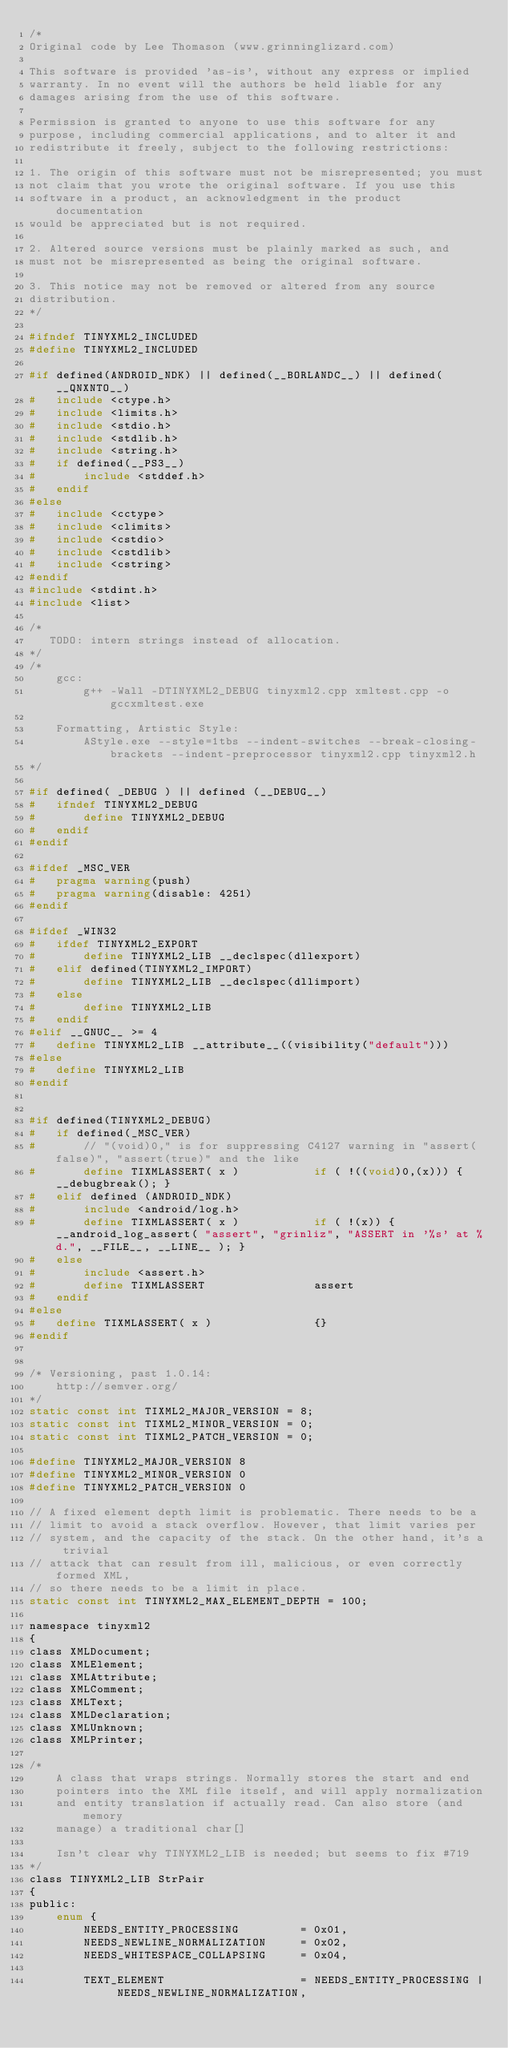Convert code to text. <code><loc_0><loc_0><loc_500><loc_500><_C_>/*
Original code by Lee Thomason (www.grinninglizard.com)

This software is provided 'as-is', without any express or implied
warranty. In no event will the authors be held liable for any
damages arising from the use of this software.

Permission is granted to anyone to use this software for any
purpose, including commercial applications, and to alter it and
redistribute it freely, subject to the following restrictions:

1. The origin of this software must not be misrepresented; you must
not claim that you wrote the original software. If you use this
software in a product, an acknowledgment in the product documentation
would be appreciated but is not required.

2. Altered source versions must be plainly marked as such, and
must not be misrepresented as being the original software.

3. This notice may not be removed or altered from any source
distribution.
*/

#ifndef TINYXML2_INCLUDED
#define TINYXML2_INCLUDED

#if defined(ANDROID_NDK) || defined(__BORLANDC__) || defined(__QNXNTO__)
#   include <ctype.h>
#   include <limits.h>
#   include <stdio.h>
#   include <stdlib.h>
#   include <string.h>
#	if defined(__PS3__)
#		include <stddef.h>
#	endif
#else
#   include <cctype>
#   include <climits>
#   include <cstdio>
#   include <cstdlib>
#   include <cstring>
#endif
#include <stdint.h>
#include <list>

/*
   TODO: intern strings instead of allocation.
*/
/*
	gcc:
        g++ -Wall -DTINYXML2_DEBUG tinyxml2.cpp xmltest.cpp -o gccxmltest.exe

    Formatting, Artistic Style:
        AStyle.exe --style=1tbs --indent-switches --break-closing-brackets --indent-preprocessor tinyxml2.cpp tinyxml2.h
*/

#if defined( _DEBUG ) || defined (__DEBUG__)
#   ifndef TINYXML2_DEBUG
#       define TINYXML2_DEBUG
#   endif
#endif

#ifdef _MSC_VER
#   pragma warning(push)
#   pragma warning(disable: 4251)
#endif

#ifdef _WIN32
#   ifdef TINYXML2_EXPORT
#       define TINYXML2_LIB __declspec(dllexport)
#   elif defined(TINYXML2_IMPORT)
#       define TINYXML2_LIB __declspec(dllimport)
#   else
#       define TINYXML2_LIB
#   endif
#elif __GNUC__ >= 4
#   define TINYXML2_LIB __attribute__((visibility("default")))
#else
#   define TINYXML2_LIB
#endif


#if defined(TINYXML2_DEBUG)
#   if defined(_MSC_VER)
#       // "(void)0," is for suppressing C4127 warning in "assert(false)", "assert(true)" and the like
#       define TIXMLASSERT( x )           if ( !((void)0,(x))) { __debugbreak(); }
#   elif defined (ANDROID_NDK)
#       include <android/log.h>
#       define TIXMLASSERT( x )           if ( !(x)) { __android_log_assert( "assert", "grinliz", "ASSERT in '%s' at %d.", __FILE__, __LINE__ ); }
#   else
#       include <assert.h>
#       define TIXMLASSERT                assert
#   endif
#else
#   define TIXMLASSERT( x )               {}
#endif


/* Versioning, past 1.0.14:
	http://semver.org/
*/
static const int TIXML2_MAJOR_VERSION = 8;
static const int TIXML2_MINOR_VERSION = 0;
static const int TIXML2_PATCH_VERSION = 0;

#define TINYXML2_MAJOR_VERSION 8
#define TINYXML2_MINOR_VERSION 0
#define TINYXML2_PATCH_VERSION 0

// A fixed element depth limit is problematic. There needs to be a
// limit to avoid a stack overflow. However, that limit varies per
// system, and the capacity of the stack. On the other hand, it's a trivial
// attack that can result from ill, malicious, or even correctly formed XML,
// so there needs to be a limit in place.
static const int TINYXML2_MAX_ELEMENT_DEPTH = 100;

namespace tinyxml2
{
class XMLDocument;
class XMLElement;
class XMLAttribute;
class XMLComment;
class XMLText;
class XMLDeclaration;
class XMLUnknown;
class XMLPrinter;

/*
	A class that wraps strings. Normally stores the start and end
	pointers into the XML file itself, and will apply normalization
	and entity translation if actually read. Can also store (and memory
	manage) a traditional char[]

    Isn't clear why TINYXML2_LIB is needed; but seems to fix #719
*/
class TINYXML2_LIB StrPair
{
public:
    enum {
        NEEDS_ENTITY_PROCESSING			= 0x01,
        NEEDS_NEWLINE_NORMALIZATION		= 0x02,
        NEEDS_WHITESPACE_COLLAPSING     = 0x04,

        TEXT_ELEMENT		            = NEEDS_ENTITY_PROCESSING | NEEDS_NEWLINE_NORMALIZATION,</code> 